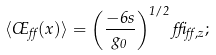<formula> <loc_0><loc_0><loc_500><loc_500>\langle \phi _ { \alpha } ( x ) \rangle = \left ( \frac { - 6 s } { g _ { 0 } } \right ) ^ { 1 / 2 } \delta _ { \alpha , z } ;</formula> 